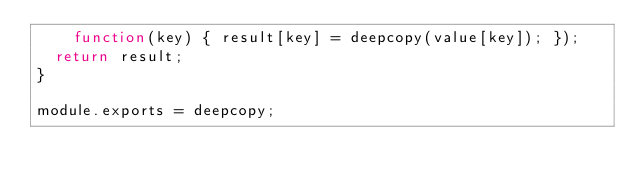<code> <loc_0><loc_0><loc_500><loc_500><_JavaScript_>    function(key) { result[key] = deepcopy(value[key]); });
  return result;
}

module.exports = deepcopy;
</code> 